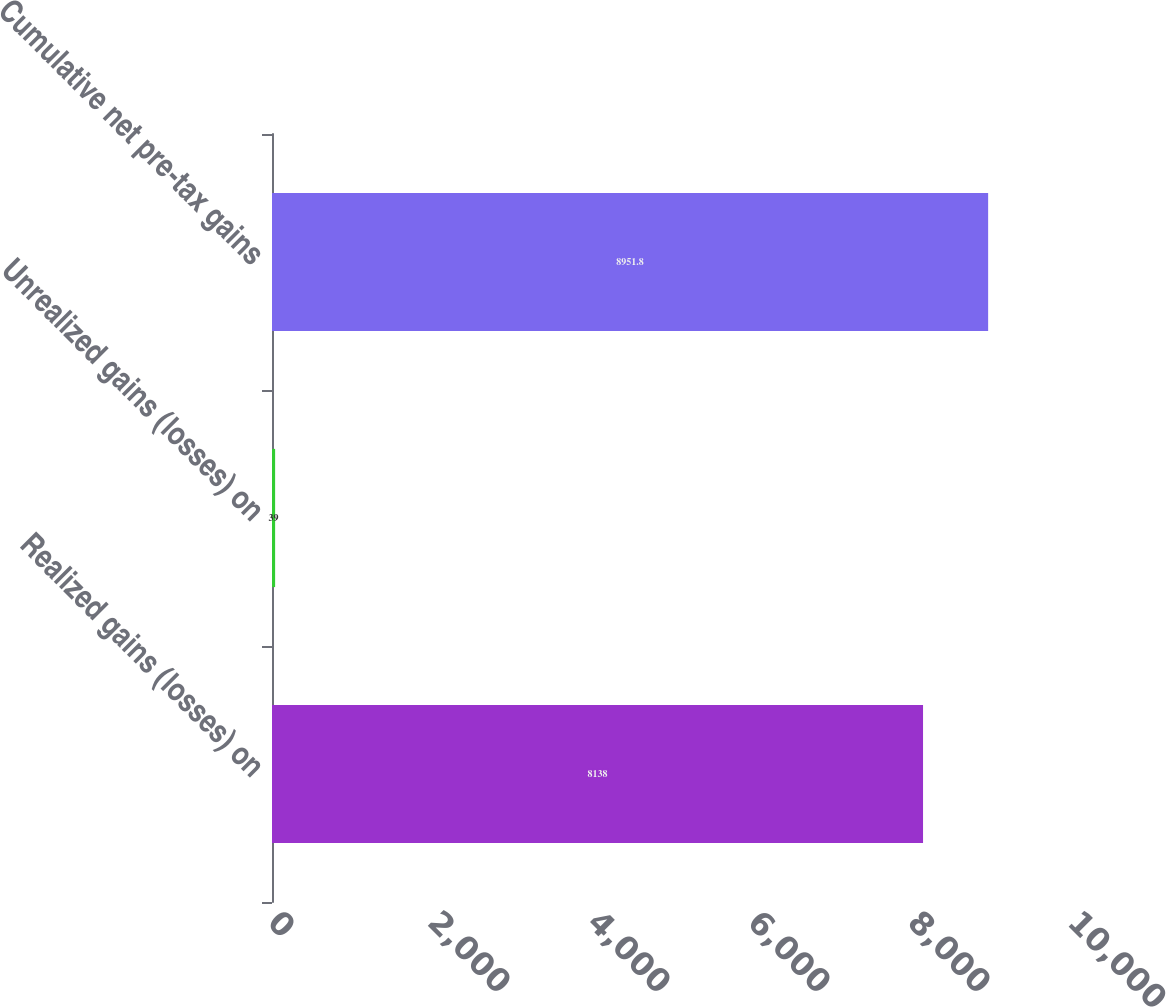Convert chart. <chart><loc_0><loc_0><loc_500><loc_500><bar_chart><fcel>Realized gains (losses) on<fcel>Unrealized gains (losses) on<fcel>Cumulative net pre-tax gains<nl><fcel>8138<fcel>39<fcel>8951.8<nl></chart> 